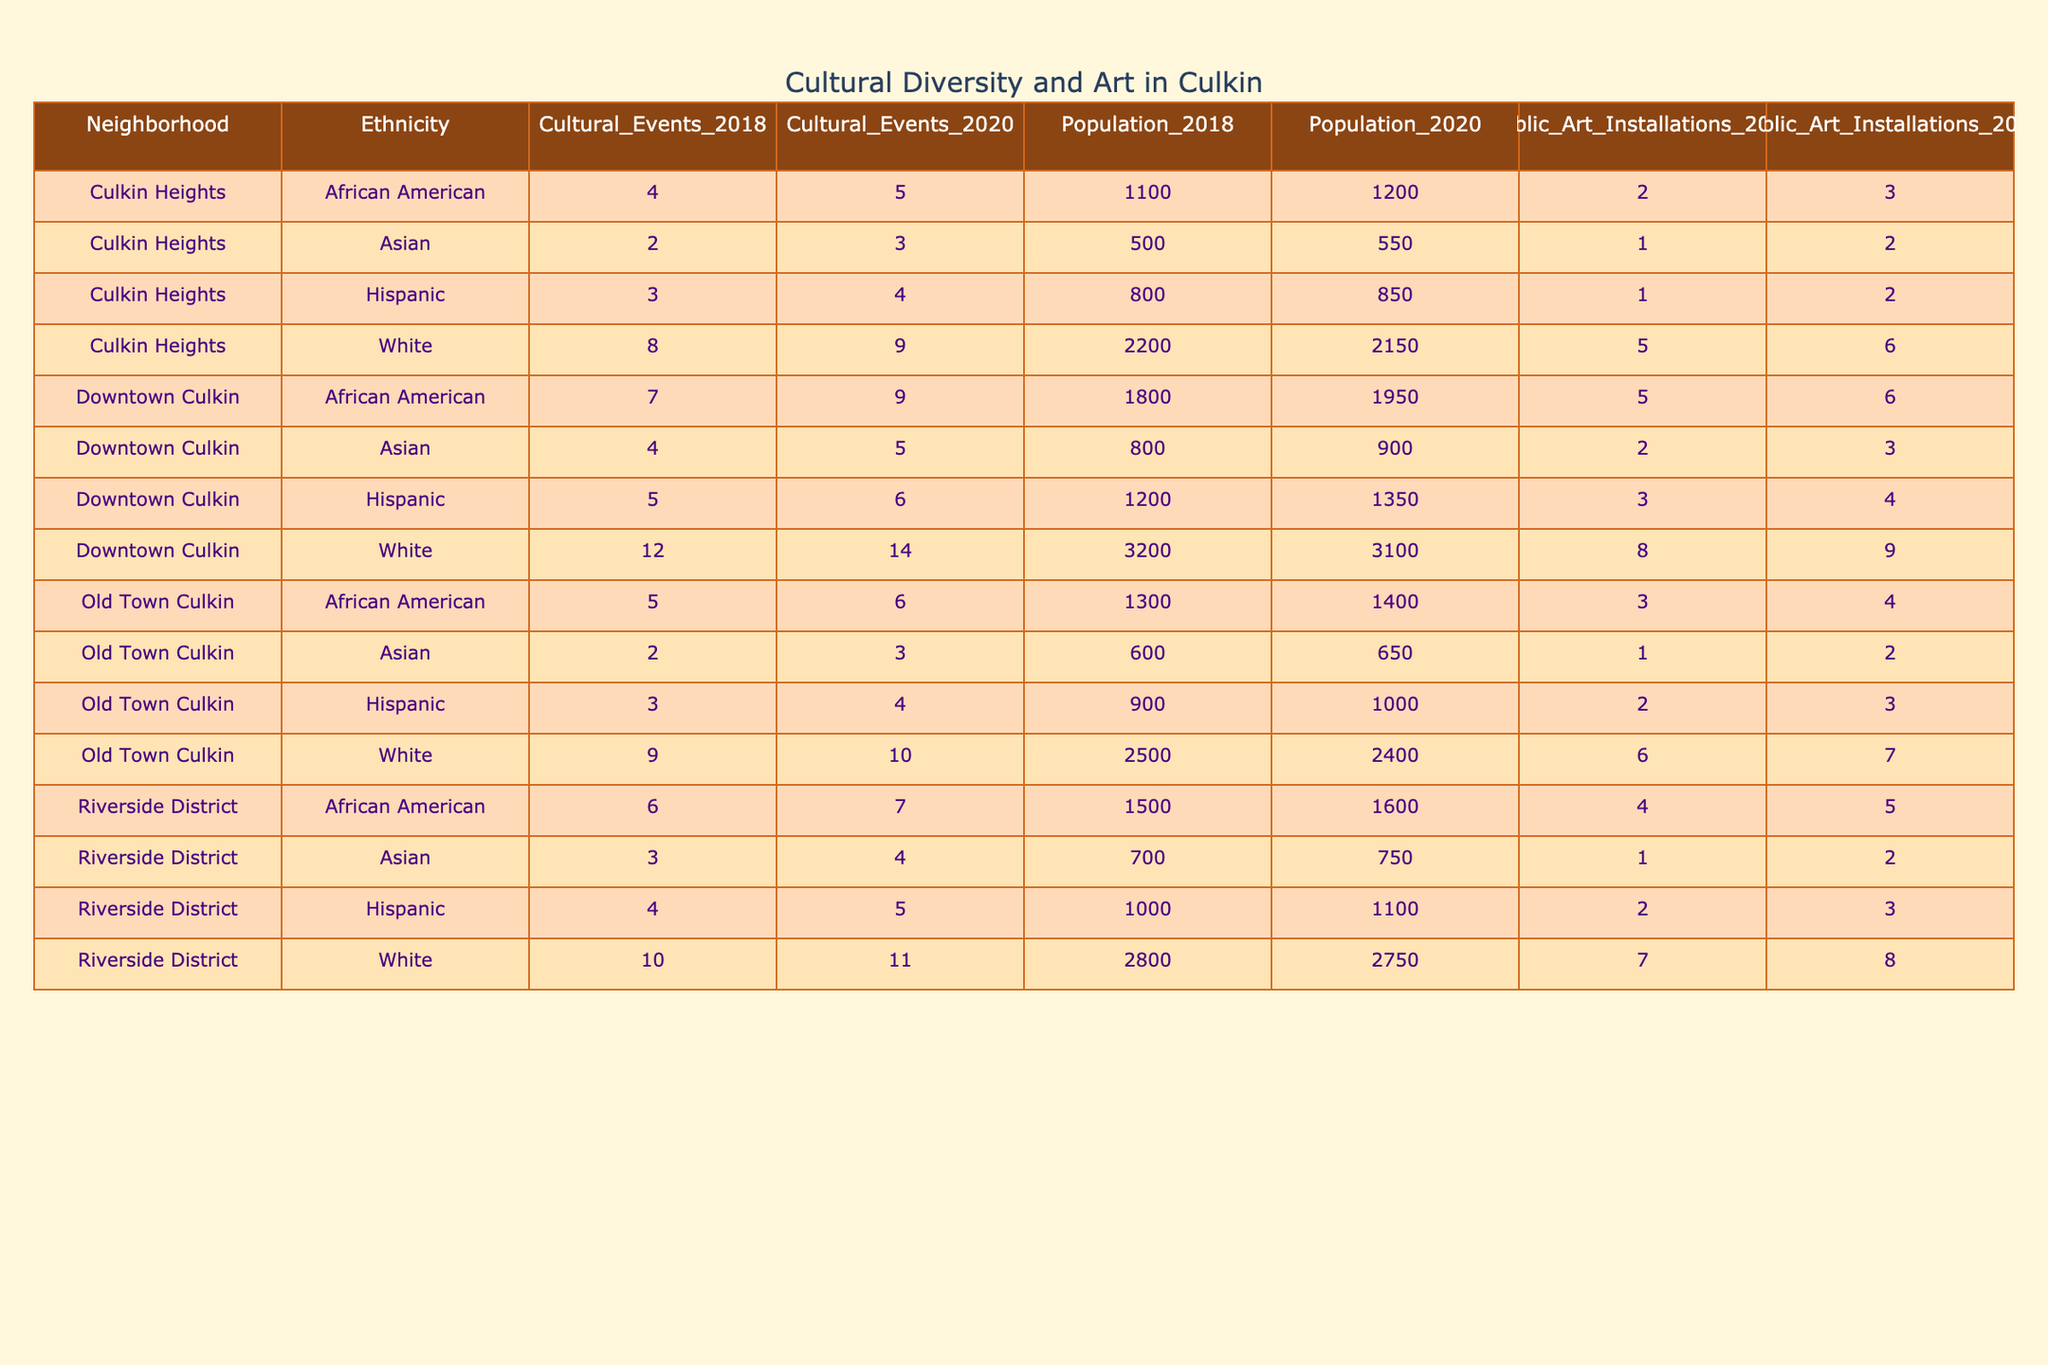What is the total population of Dowtown Culkin in 2018? The total population can be found by looking at the rows for Downtown Culkin in the year 2018. The populations are: White 3200, African American 1800, Hispanic 1200, and Asian 800. Summing these gives: 3200 + 1800 + 1200 + 800 = 7000.
Answer: 7000 What was the increase in the number of Cultural Events in Riverside District from 2018 to 2020? In Riverside District for 2018, there were 10 Cultural Events, while in 2020 there were 11. The increase can be calculated as: 11 - 10 = 1.
Answer: 1 Is there a higher total population in Old Town Culkin for 2020 compared to 2018? For 2020 in Old Town Culkin, the total population is: White 2400, African American 1400, Hispanic 1000, and Asian 650 summing to 4400. For 2018, it's: White 2500, African American 1300, Hispanic 900, and Asian 600 summing to 4300. Since 4400 > 4300, the answer is yes.
Answer: Yes What is the average number of Public Art Installations for Culkin Heights in 2020? To find the average for Culkin Heights in 2020, we take the number of Public Art Installations: White 6, African American 3, Hispanic 2, and Asian 2. We sum these up: 6 + 3 + 2 + 2 = 13, and there are 4 groups, so the average is 13 / 4 = 3.25.
Answer: 3.25 Which neighborhood had the highest population increase from 2018 to 2020, and what was the increase? We need to compare the population for each ethnicity in all neighborhoods. For Downtown Culkin, the population decreased by 100 (3200 to 3100). Riverside District decreased by 50 (2800 to 2750). Old Town Culkin decreased by 100 (2500 to 2400). Culkin Heights decreased by 50 (2200 to 2150). The highest population decrease was in Downtown Culkin and Old Town Culkin, both by 100.
Answer: Downtown Culkin and Old Town Culkin, 100 What was the total number of Cultural Events in Culkin Heights during 2018? By examining the data for Culkin Heights in 2018: White had 8 events, African American had 4, Hispanic had 3, and Asian had 2. Summing these gives: 8 + 4 + 3 + 2 = 17.
Answer: 17 Was there any ethnicity in Downtown Culkin that had more Cultural Events than Public Art Installations in 2020? In 2020, the Cultural Events for Downtown Culkin were: White 14, African American 9, Hispanic 6, Asian 5. The Public Art Installations were: White 9, African American 6, Hispanic 4, Asian 3. White (14 > 9), African American (9 > 6), and Hispanic (6 > 4) all had more Cultural Events than Public Art Installations.
Answer: Yes Which neighborhood experienced a decline in the number of African American residents from 2018 to 2020? Looking specifically for African American populations, Downtown Culkin had an increase (1800 to 1950), Riverside District had an increase (1500 to 1600), Old Town Culkin had an increase (1300 to 1400), but Culkin Heights decreased (1100 to 1200). Therefore, Culkin Heights is the neighborhood that experienced a decline in African American residents.
Answer: Culkin Heights 